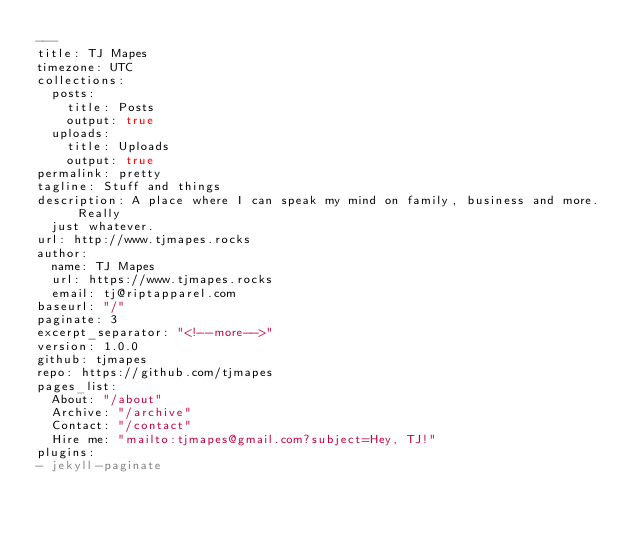Convert code to text. <code><loc_0><loc_0><loc_500><loc_500><_YAML_>---
title: TJ Mapes
timezone: UTC
collections:
  posts:
    title: Posts
    output: true
  uploads:
    title: Uploads
    output: true
permalink: pretty
tagline: Stuff and things
description: A place where I can speak my mind on family, business and more.  Really
  just whatever.
url: http://www.tjmapes.rocks
author:
  name: TJ Mapes
  url: https://www.tjmapes.rocks
  email: tj@riptapparel.com
baseurl: "/"
paginate: 3
excerpt_separator: "<!--more-->"
version: 1.0.0
github: tjmapes
repo: https://github.com/tjmapes
pages_list:
  About: "/about"
  Archive: "/archive"
  Contact: "/contact"
  Hire me: "mailto:tjmapes@gmail.com?subject=Hey, TJ!"
plugins:
- jekyll-paginate
</code> 